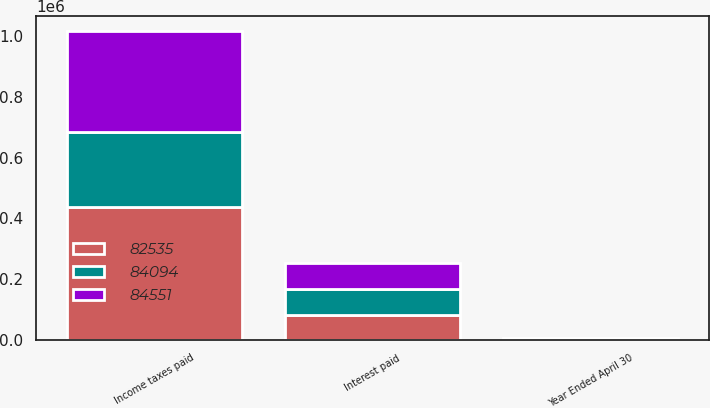<chart> <loc_0><loc_0><loc_500><loc_500><stacked_bar_chart><ecel><fcel>Year Ended April 30<fcel>Income taxes paid<fcel>Interest paid<nl><fcel>82535<fcel>2005<fcel>437427<fcel>82535<nl><fcel>84551<fcel>2004<fcel>331635<fcel>84551<nl><fcel>84094<fcel>2003<fcel>247057<fcel>84094<nl></chart> 